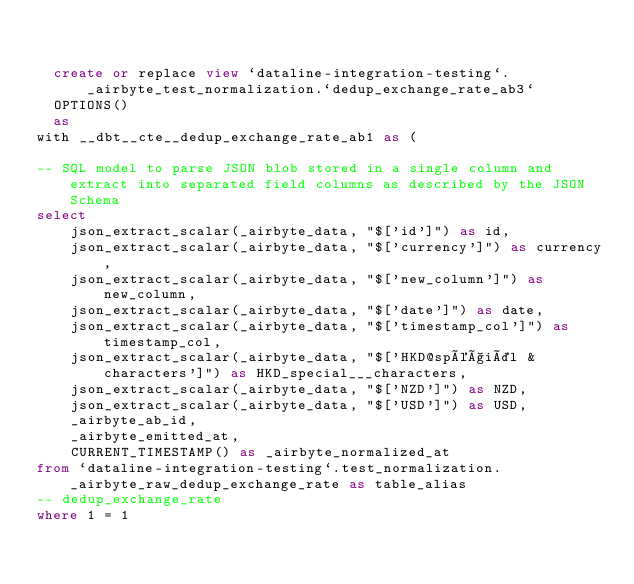<code> <loc_0><loc_0><loc_500><loc_500><_SQL_>

  create or replace view `dataline-integration-testing`._airbyte_test_normalization.`dedup_exchange_rate_ab3`
  OPTIONS()
  as 
with __dbt__cte__dedup_exchange_rate_ab1 as (

-- SQL model to parse JSON blob stored in a single column and extract into separated field columns as described by the JSON Schema
select
    json_extract_scalar(_airbyte_data, "$['id']") as id,
    json_extract_scalar(_airbyte_data, "$['currency']") as currency,
    json_extract_scalar(_airbyte_data, "$['new_column']") as new_column,
    json_extract_scalar(_airbyte_data, "$['date']") as date,
    json_extract_scalar(_airbyte_data, "$['timestamp_col']") as timestamp_col,
    json_extract_scalar(_airbyte_data, "$['HKD@spéçiäl & characters']") as HKD_special___characters,
    json_extract_scalar(_airbyte_data, "$['NZD']") as NZD,
    json_extract_scalar(_airbyte_data, "$['USD']") as USD,
    _airbyte_ab_id,
    _airbyte_emitted_at,
    CURRENT_TIMESTAMP() as _airbyte_normalized_at
from `dataline-integration-testing`.test_normalization._airbyte_raw_dedup_exchange_rate as table_alias
-- dedup_exchange_rate
where 1 = 1
</code> 